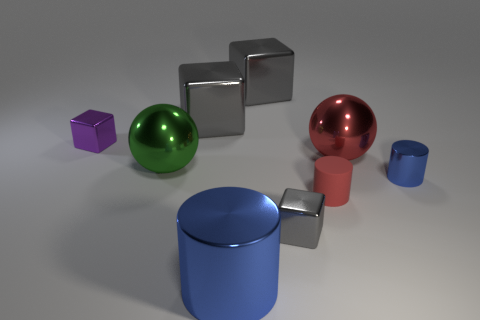Subtract all gray cubes. How many were subtracted if there are1gray cubes left? 2 Subtract all cyan cylinders. How many gray blocks are left? 3 Subtract 1 blocks. How many blocks are left? 3 Subtract all cylinders. How many objects are left? 6 Add 1 small green things. How many objects exist? 10 Add 1 large blue metallic cylinders. How many large blue metallic cylinders are left? 2 Add 4 tiny purple shiny blocks. How many tiny purple shiny blocks exist? 5 Subtract 0 gray cylinders. How many objects are left? 9 Subtract all big blue cylinders. Subtract all small gray shiny blocks. How many objects are left? 7 